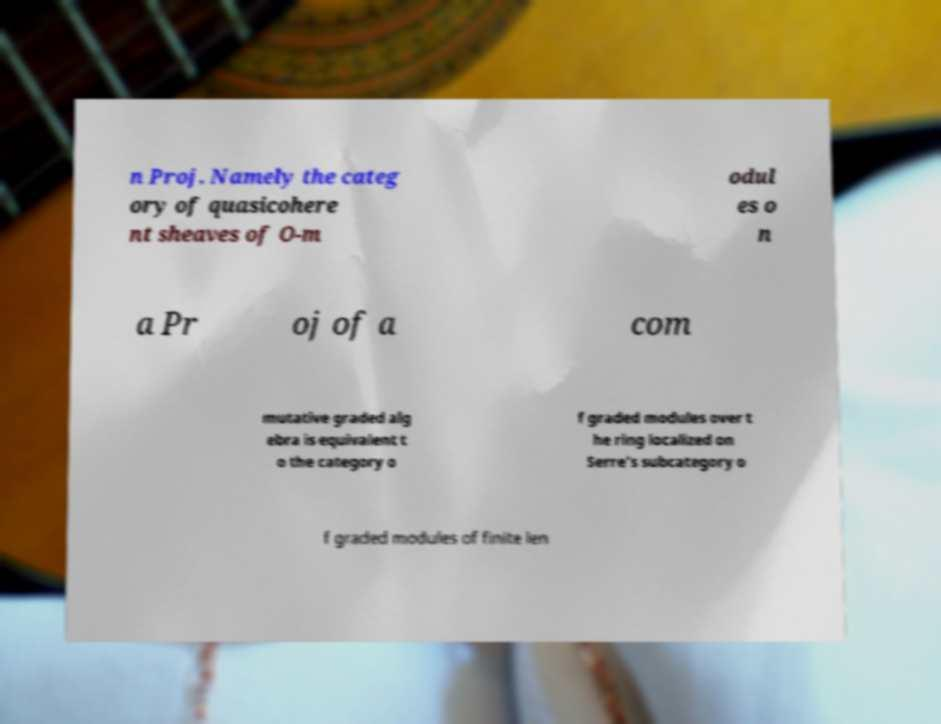Can you accurately transcribe the text from the provided image for me? n Proj. Namely the categ ory of quasicohere nt sheaves of O-m odul es o n a Pr oj of a com mutative graded alg ebra is equivalent t o the category o f graded modules over t he ring localized on Serre's subcategory o f graded modules of finite len 